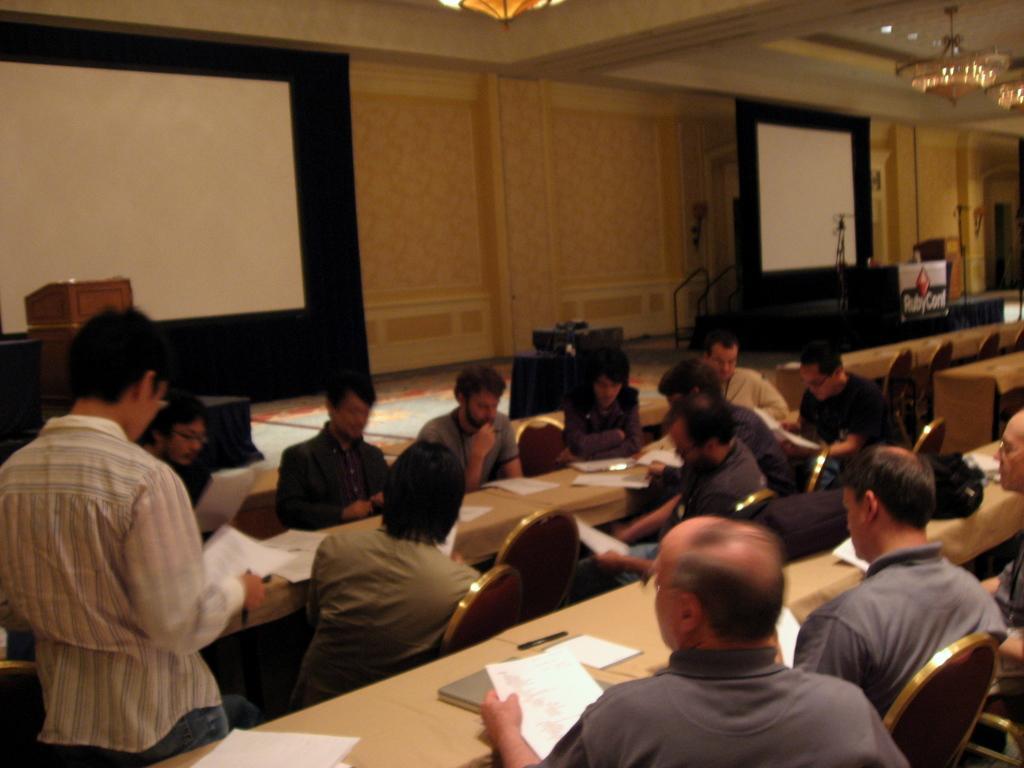In one or two sentences, can you explain what this image depicts? In this image I can see number of people are sitting on chairs and on the left side I can see one man is standing. I can also see most of them are holding papers and I can also see number of tables. On these tables I can see number of white colour papers and few other stuffs. In the background I can see two projector screens, few stands, few podiums and on the top side I can see few lights on the ceiling. 